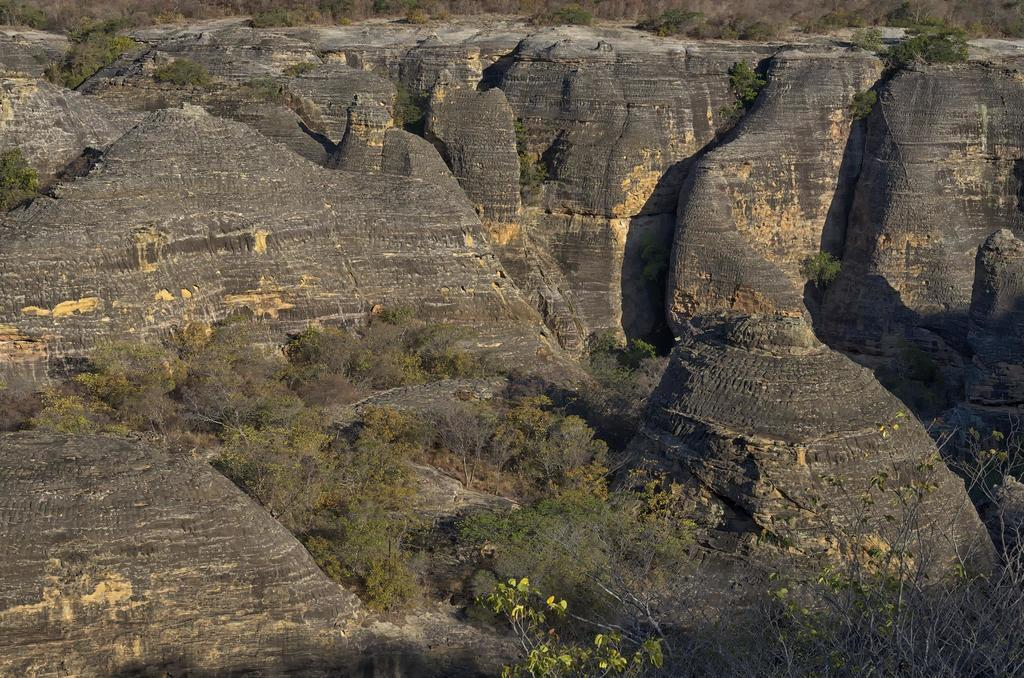Where was the image taken? The image was taken outdoors. What geographical features can be seen in the image? There are many hills in the image. What natural elements are present in the image? There are rocks, trees, and plants in the image. Can you see any rabbits playing in the image? There are no rabbits or any indication of play in the image. What type of vegetable is growing among the plants in the image? There is no vegetable visible in the image; only plants are present. 